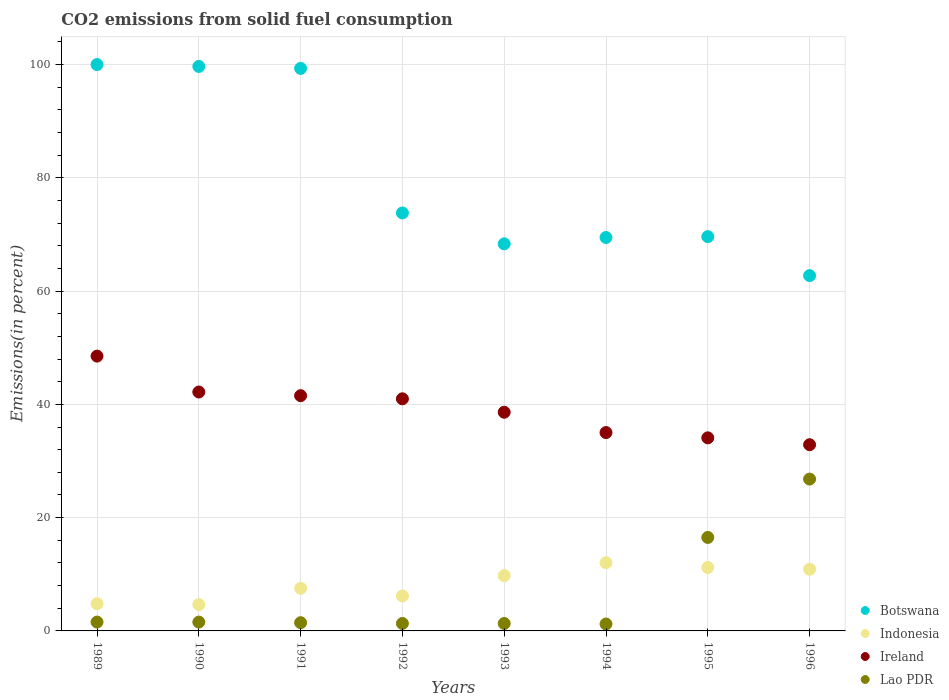Is the number of dotlines equal to the number of legend labels?
Keep it short and to the point. Yes. What is the total CO2 emitted in Ireland in 1990?
Give a very brief answer. 42.18. Across all years, what is the minimum total CO2 emitted in Botswana?
Give a very brief answer. 62.73. In which year was the total CO2 emitted in Ireland maximum?
Your answer should be compact. 1989. In which year was the total CO2 emitted in Botswana minimum?
Give a very brief answer. 1996. What is the total total CO2 emitted in Lao PDR in the graph?
Offer a terse response. 51.74. What is the difference between the total CO2 emitted in Lao PDR in 1989 and that in 1995?
Your answer should be very brief. -14.94. What is the difference between the total CO2 emitted in Ireland in 1994 and the total CO2 emitted in Indonesia in 1989?
Make the answer very short. 30.22. What is the average total CO2 emitted in Lao PDR per year?
Offer a terse response. 6.47. In the year 1993, what is the difference between the total CO2 emitted in Botswana and total CO2 emitted in Indonesia?
Your answer should be compact. 58.59. In how many years, is the total CO2 emitted in Ireland greater than 4 %?
Your answer should be compact. 8. What is the ratio of the total CO2 emitted in Ireland in 1989 to that in 1995?
Ensure brevity in your answer.  1.42. What is the difference between the highest and the second highest total CO2 emitted in Ireland?
Offer a terse response. 6.34. What is the difference between the highest and the lowest total CO2 emitted in Ireland?
Make the answer very short. 15.64. Is it the case that in every year, the sum of the total CO2 emitted in Lao PDR and total CO2 emitted in Indonesia  is greater than the sum of total CO2 emitted in Ireland and total CO2 emitted in Botswana?
Offer a very short reply. No. Is the total CO2 emitted in Botswana strictly less than the total CO2 emitted in Ireland over the years?
Your answer should be very brief. No. How many dotlines are there?
Keep it short and to the point. 4. What is the difference between two consecutive major ticks on the Y-axis?
Provide a succinct answer. 20. Are the values on the major ticks of Y-axis written in scientific E-notation?
Offer a very short reply. No. Does the graph contain any zero values?
Keep it short and to the point. No. Does the graph contain grids?
Provide a succinct answer. Yes. Where does the legend appear in the graph?
Offer a terse response. Bottom right. How are the legend labels stacked?
Provide a short and direct response. Vertical. What is the title of the graph?
Provide a short and direct response. CO2 emissions from solid fuel consumption. What is the label or title of the X-axis?
Keep it short and to the point. Years. What is the label or title of the Y-axis?
Provide a succinct answer. Emissions(in percent). What is the Emissions(in percent) of Botswana in 1989?
Provide a succinct answer. 100. What is the Emissions(in percent) of Indonesia in 1989?
Ensure brevity in your answer.  4.8. What is the Emissions(in percent) in Ireland in 1989?
Provide a succinct answer. 48.52. What is the Emissions(in percent) of Lao PDR in 1989?
Your answer should be very brief. 1.56. What is the Emissions(in percent) of Botswana in 1990?
Your answer should be compact. 99.66. What is the Emissions(in percent) in Indonesia in 1990?
Provide a succinct answer. 4.65. What is the Emissions(in percent) of Ireland in 1990?
Make the answer very short. 42.18. What is the Emissions(in percent) in Lao PDR in 1990?
Keep it short and to the point. 1.56. What is the Emissions(in percent) in Botswana in 1991?
Your answer should be compact. 99.32. What is the Emissions(in percent) in Indonesia in 1991?
Your answer should be very brief. 7.53. What is the Emissions(in percent) in Ireland in 1991?
Provide a succinct answer. 41.53. What is the Emissions(in percent) of Lao PDR in 1991?
Provide a succinct answer. 1.45. What is the Emissions(in percent) in Botswana in 1992?
Offer a very short reply. 73.8. What is the Emissions(in percent) of Indonesia in 1992?
Offer a very short reply. 6.18. What is the Emissions(in percent) of Ireland in 1992?
Offer a very short reply. 40.98. What is the Emissions(in percent) of Lao PDR in 1992?
Provide a short and direct response. 1.32. What is the Emissions(in percent) in Botswana in 1993?
Provide a short and direct response. 68.34. What is the Emissions(in percent) of Indonesia in 1993?
Keep it short and to the point. 9.76. What is the Emissions(in percent) in Ireland in 1993?
Offer a very short reply. 38.61. What is the Emissions(in percent) of Lao PDR in 1993?
Offer a terse response. 1.32. What is the Emissions(in percent) in Botswana in 1994?
Give a very brief answer. 69.46. What is the Emissions(in percent) of Indonesia in 1994?
Provide a short and direct response. 12.05. What is the Emissions(in percent) in Ireland in 1994?
Your answer should be compact. 35.02. What is the Emissions(in percent) in Lao PDR in 1994?
Make the answer very short. 1.22. What is the Emissions(in percent) in Botswana in 1995?
Your response must be concise. 69.61. What is the Emissions(in percent) in Indonesia in 1995?
Your answer should be compact. 11.2. What is the Emissions(in percent) of Ireland in 1995?
Offer a terse response. 34.09. What is the Emissions(in percent) in Lao PDR in 1995?
Provide a short and direct response. 16.5. What is the Emissions(in percent) of Botswana in 1996?
Give a very brief answer. 62.73. What is the Emissions(in percent) of Indonesia in 1996?
Your answer should be compact. 10.89. What is the Emissions(in percent) in Ireland in 1996?
Give a very brief answer. 32.88. What is the Emissions(in percent) in Lao PDR in 1996?
Offer a very short reply. 26.81. Across all years, what is the maximum Emissions(in percent) in Botswana?
Provide a succinct answer. 100. Across all years, what is the maximum Emissions(in percent) of Indonesia?
Ensure brevity in your answer.  12.05. Across all years, what is the maximum Emissions(in percent) of Ireland?
Give a very brief answer. 48.52. Across all years, what is the maximum Emissions(in percent) in Lao PDR?
Offer a very short reply. 26.81. Across all years, what is the minimum Emissions(in percent) of Botswana?
Your answer should be very brief. 62.73. Across all years, what is the minimum Emissions(in percent) in Indonesia?
Give a very brief answer. 4.65. Across all years, what is the minimum Emissions(in percent) in Ireland?
Provide a short and direct response. 32.88. Across all years, what is the minimum Emissions(in percent) in Lao PDR?
Give a very brief answer. 1.22. What is the total Emissions(in percent) in Botswana in the graph?
Make the answer very short. 642.93. What is the total Emissions(in percent) of Indonesia in the graph?
Ensure brevity in your answer.  67.05. What is the total Emissions(in percent) in Ireland in the graph?
Make the answer very short. 313.82. What is the total Emissions(in percent) in Lao PDR in the graph?
Provide a short and direct response. 51.74. What is the difference between the Emissions(in percent) of Botswana in 1989 and that in 1990?
Your answer should be very brief. 0.34. What is the difference between the Emissions(in percent) in Indonesia in 1989 and that in 1990?
Offer a terse response. 0.15. What is the difference between the Emissions(in percent) in Ireland in 1989 and that in 1990?
Make the answer very short. 6.34. What is the difference between the Emissions(in percent) in Botswana in 1989 and that in 1991?
Ensure brevity in your answer.  0.68. What is the difference between the Emissions(in percent) in Indonesia in 1989 and that in 1991?
Ensure brevity in your answer.  -2.73. What is the difference between the Emissions(in percent) of Ireland in 1989 and that in 1991?
Provide a succinct answer. 6.99. What is the difference between the Emissions(in percent) of Lao PDR in 1989 and that in 1991?
Your answer should be very brief. 0.11. What is the difference between the Emissions(in percent) in Botswana in 1989 and that in 1992?
Keep it short and to the point. 26.2. What is the difference between the Emissions(in percent) in Indonesia in 1989 and that in 1992?
Your answer should be compact. -1.38. What is the difference between the Emissions(in percent) of Ireland in 1989 and that in 1992?
Provide a short and direct response. 7.54. What is the difference between the Emissions(in percent) of Lao PDR in 1989 and that in 1992?
Keep it short and to the point. 0.25. What is the difference between the Emissions(in percent) of Botswana in 1989 and that in 1993?
Make the answer very short. 31.66. What is the difference between the Emissions(in percent) in Indonesia in 1989 and that in 1993?
Your response must be concise. -4.96. What is the difference between the Emissions(in percent) in Ireland in 1989 and that in 1993?
Provide a succinct answer. 9.91. What is the difference between the Emissions(in percent) of Lao PDR in 1989 and that in 1993?
Offer a very short reply. 0.25. What is the difference between the Emissions(in percent) of Botswana in 1989 and that in 1994?
Ensure brevity in your answer.  30.54. What is the difference between the Emissions(in percent) in Indonesia in 1989 and that in 1994?
Provide a succinct answer. -7.25. What is the difference between the Emissions(in percent) in Ireland in 1989 and that in 1994?
Offer a terse response. 13.5. What is the difference between the Emissions(in percent) in Lao PDR in 1989 and that in 1994?
Your response must be concise. 0.34. What is the difference between the Emissions(in percent) of Botswana in 1989 and that in 1995?
Make the answer very short. 30.39. What is the difference between the Emissions(in percent) in Indonesia in 1989 and that in 1995?
Provide a succinct answer. -6.4. What is the difference between the Emissions(in percent) of Ireland in 1989 and that in 1995?
Make the answer very short. 14.43. What is the difference between the Emissions(in percent) of Lao PDR in 1989 and that in 1995?
Keep it short and to the point. -14.94. What is the difference between the Emissions(in percent) of Botswana in 1989 and that in 1996?
Offer a terse response. 37.27. What is the difference between the Emissions(in percent) of Indonesia in 1989 and that in 1996?
Provide a short and direct response. -6.09. What is the difference between the Emissions(in percent) of Ireland in 1989 and that in 1996?
Your response must be concise. 15.64. What is the difference between the Emissions(in percent) of Lao PDR in 1989 and that in 1996?
Ensure brevity in your answer.  -25.25. What is the difference between the Emissions(in percent) in Botswana in 1990 and that in 1991?
Make the answer very short. 0.35. What is the difference between the Emissions(in percent) of Indonesia in 1990 and that in 1991?
Ensure brevity in your answer.  -2.88. What is the difference between the Emissions(in percent) of Ireland in 1990 and that in 1991?
Offer a terse response. 0.65. What is the difference between the Emissions(in percent) of Lao PDR in 1990 and that in 1991?
Keep it short and to the point. 0.11. What is the difference between the Emissions(in percent) of Botswana in 1990 and that in 1992?
Make the answer very short. 25.87. What is the difference between the Emissions(in percent) of Indonesia in 1990 and that in 1992?
Your response must be concise. -1.53. What is the difference between the Emissions(in percent) in Ireland in 1990 and that in 1992?
Your answer should be very brief. 1.2. What is the difference between the Emissions(in percent) of Lao PDR in 1990 and that in 1992?
Your answer should be compact. 0.25. What is the difference between the Emissions(in percent) of Botswana in 1990 and that in 1993?
Offer a terse response. 31.32. What is the difference between the Emissions(in percent) in Indonesia in 1990 and that in 1993?
Provide a short and direct response. -5.11. What is the difference between the Emissions(in percent) of Ireland in 1990 and that in 1993?
Your answer should be compact. 3.57. What is the difference between the Emissions(in percent) of Lao PDR in 1990 and that in 1993?
Offer a very short reply. 0.25. What is the difference between the Emissions(in percent) in Botswana in 1990 and that in 1994?
Make the answer very short. 30.2. What is the difference between the Emissions(in percent) in Indonesia in 1990 and that in 1994?
Your answer should be compact. -7.4. What is the difference between the Emissions(in percent) in Ireland in 1990 and that in 1994?
Offer a terse response. 7.16. What is the difference between the Emissions(in percent) of Lao PDR in 1990 and that in 1994?
Offer a terse response. 0.34. What is the difference between the Emissions(in percent) of Botswana in 1990 and that in 1995?
Give a very brief answer. 30.05. What is the difference between the Emissions(in percent) in Indonesia in 1990 and that in 1995?
Make the answer very short. -6.55. What is the difference between the Emissions(in percent) of Ireland in 1990 and that in 1995?
Ensure brevity in your answer.  8.09. What is the difference between the Emissions(in percent) of Lao PDR in 1990 and that in 1995?
Offer a terse response. -14.94. What is the difference between the Emissions(in percent) of Botswana in 1990 and that in 1996?
Your answer should be very brief. 36.93. What is the difference between the Emissions(in percent) of Indonesia in 1990 and that in 1996?
Keep it short and to the point. -6.24. What is the difference between the Emissions(in percent) of Ireland in 1990 and that in 1996?
Give a very brief answer. 9.3. What is the difference between the Emissions(in percent) in Lao PDR in 1990 and that in 1996?
Provide a succinct answer. -25.25. What is the difference between the Emissions(in percent) of Botswana in 1991 and that in 1992?
Offer a terse response. 25.52. What is the difference between the Emissions(in percent) in Indonesia in 1991 and that in 1992?
Make the answer very short. 1.35. What is the difference between the Emissions(in percent) in Ireland in 1991 and that in 1992?
Provide a short and direct response. 0.55. What is the difference between the Emissions(in percent) of Lao PDR in 1991 and that in 1992?
Ensure brevity in your answer.  0.13. What is the difference between the Emissions(in percent) of Botswana in 1991 and that in 1993?
Offer a very short reply. 30.97. What is the difference between the Emissions(in percent) in Indonesia in 1991 and that in 1993?
Offer a terse response. -2.23. What is the difference between the Emissions(in percent) in Ireland in 1991 and that in 1993?
Your answer should be compact. 2.92. What is the difference between the Emissions(in percent) of Lao PDR in 1991 and that in 1993?
Ensure brevity in your answer.  0.13. What is the difference between the Emissions(in percent) of Botswana in 1991 and that in 1994?
Your answer should be very brief. 29.85. What is the difference between the Emissions(in percent) of Indonesia in 1991 and that in 1994?
Ensure brevity in your answer.  -4.52. What is the difference between the Emissions(in percent) of Ireland in 1991 and that in 1994?
Keep it short and to the point. 6.51. What is the difference between the Emissions(in percent) in Lao PDR in 1991 and that in 1994?
Provide a succinct answer. 0.23. What is the difference between the Emissions(in percent) in Botswana in 1991 and that in 1995?
Your answer should be compact. 29.7. What is the difference between the Emissions(in percent) in Indonesia in 1991 and that in 1995?
Offer a terse response. -3.67. What is the difference between the Emissions(in percent) in Ireland in 1991 and that in 1995?
Provide a short and direct response. 7.44. What is the difference between the Emissions(in percent) of Lao PDR in 1991 and that in 1995?
Ensure brevity in your answer.  -15.06. What is the difference between the Emissions(in percent) in Botswana in 1991 and that in 1996?
Keep it short and to the point. 36.58. What is the difference between the Emissions(in percent) in Indonesia in 1991 and that in 1996?
Give a very brief answer. -3.36. What is the difference between the Emissions(in percent) of Ireland in 1991 and that in 1996?
Give a very brief answer. 8.66. What is the difference between the Emissions(in percent) of Lao PDR in 1991 and that in 1996?
Offer a very short reply. -25.36. What is the difference between the Emissions(in percent) in Botswana in 1992 and that in 1993?
Give a very brief answer. 5.45. What is the difference between the Emissions(in percent) in Indonesia in 1992 and that in 1993?
Your answer should be very brief. -3.58. What is the difference between the Emissions(in percent) in Ireland in 1992 and that in 1993?
Keep it short and to the point. 2.37. What is the difference between the Emissions(in percent) in Botswana in 1992 and that in 1994?
Provide a short and direct response. 4.33. What is the difference between the Emissions(in percent) in Indonesia in 1992 and that in 1994?
Offer a terse response. -5.87. What is the difference between the Emissions(in percent) of Ireland in 1992 and that in 1994?
Provide a succinct answer. 5.96. What is the difference between the Emissions(in percent) in Lao PDR in 1992 and that in 1994?
Offer a very short reply. 0.1. What is the difference between the Emissions(in percent) of Botswana in 1992 and that in 1995?
Make the answer very short. 4.18. What is the difference between the Emissions(in percent) of Indonesia in 1992 and that in 1995?
Your response must be concise. -5.02. What is the difference between the Emissions(in percent) of Ireland in 1992 and that in 1995?
Offer a terse response. 6.89. What is the difference between the Emissions(in percent) of Lao PDR in 1992 and that in 1995?
Provide a succinct answer. -15.19. What is the difference between the Emissions(in percent) of Botswana in 1992 and that in 1996?
Keep it short and to the point. 11.06. What is the difference between the Emissions(in percent) of Indonesia in 1992 and that in 1996?
Give a very brief answer. -4.71. What is the difference between the Emissions(in percent) of Ireland in 1992 and that in 1996?
Give a very brief answer. 8.1. What is the difference between the Emissions(in percent) of Lao PDR in 1992 and that in 1996?
Ensure brevity in your answer.  -25.5. What is the difference between the Emissions(in percent) of Botswana in 1993 and that in 1994?
Give a very brief answer. -1.12. What is the difference between the Emissions(in percent) in Indonesia in 1993 and that in 1994?
Provide a short and direct response. -2.29. What is the difference between the Emissions(in percent) of Ireland in 1993 and that in 1994?
Give a very brief answer. 3.59. What is the difference between the Emissions(in percent) of Lao PDR in 1993 and that in 1994?
Provide a succinct answer. 0.1. What is the difference between the Emissions(in percent) of Botswana in 1993 and that in 1995?
Provide a short and direct response. -1.27. What is the difference between the Emissions(in percent) of Indonesia in 1993 and that in 1995?
Your answer should be very brief. -1.44. What is the difference between the Emissions(in percent) of Ireland in 1993 and that in 1995?
Offer a terse response. 4.52. What is the difference between the Emissions(in percent) of Lao PDR in 1993 and that in 1995?
Ensure brevity in your answer.  -15.19. What is the difference between the Emissions(in percent) in Botswana in 1993 and that in 1996?
Provide a succinct answer. 5.61. What is the difference between the Emissions(in percent) of Indonesia in 1993 and that in 1996?
Make the answer very short. -1.13. What is the difference between the Emissions(in percent) of Ireland in 1993 and that in 1996?
Your answer should be very brief. 5.73. What is the difference between the Emissions(in percent) in Lao PDR in 1993 and that in 1996?
Offer a terse response. -25.5. What is the difference between the Emissions(in percent) of Botswana in 1994 and that in 1995?
Offer a very short reply. -0.15. What is the difference between the Emissions(in percent) of Indonesia in 1994 and that in 1995?
Ensure brevity in your answer.  0.84. What is the difference between the Emissions(in percent) in Ireland in 1994 and that in 1995?
Your answer should be compact. 0.93. What is the difference between the Emissions(in percent) in Lao PDR in 1994 and that in 1995?
Your answer should be compact. -15.29. What is the difference between the Emissions(in percent) in Botswana in 1994 and that in 1996?
Keep it short and to the point. 6.73. What is the difference between the Emissions(in percent) of Indonesia in 1994 and that in 1996?
Ensure brevity in your answer.  1.16. What is the difference between the Emissions(in percent) of Ireland in 1994 and that in 1996?
Give a very brief answer. 2.14. What is the difference between the Emissions(in percent) of Lao PDR in 1994 and that in 1996?
Your response must be concise. -25.59. What is the difference between the Emissions(in percent) in Botswana in 1995 and that in 1996?
Give a very brief answer. 6.88. What is the difference between the Emissions(in percent) of Indonesia in 1995 and that in 1996?
Offer a terse response. 0.31. What is the difference between the Emissions(in percent) of Ireland in 1995 and that in 1996?
Your answer should be compact. 1.21. What is the difference between the Emissions(in percent) of Lao PDR in 1995 and that in 1996?
Your answer should be very brief. -10.31. What is the difference between the Emissions(in percent) in Botswana in 1989 and the Emissions(in percent) in Indonesia in 1990?
Your answer should be compact. 95.35. What is the difference between the Emissions(in percent) of Botswana in 1989 and the Emissions(in percent) of Ireland in 1990?
Provide a short and direct response. 57.82. What is the difference between the Emissions(in percent) in Botswana in 1989 and the Emissions(in percent) in Lao PDR in 1990?
Give a very brief answer. 98.44. What is the difference between the Emissions(in percent) in Indonesia in 1989 and the Emissions(in percent) in Ireland in 1990?
Your answer should be compact. -37.38. What is the difference between the Emissions(in percent) in Indonesia in 1989 and the Emissions(in percent) in Lao PDR in 1990?
Your answer should be very brief. 3.24. What is the difference between the Emissions(in percent) of Ireland in 1989 and the Emissions(in percent) of Lao PDR in 1990?
Keep it short and to the point. 46.96. What is the difference between the Emissions(in percent) of Botswana in 1989 and the Emissions(in percent) of Indonesia in 1991?
Your response must be concise. 92.47. What is the difference between the Emissions(in percent) of Botswana in 1989 and the Emissions(in percent) of Ireland in 1991?
Your answer should be compact. 58.47. What is the difference between the Emissions(in percent) in Botswana in 1989 and the Emissions(in percent) in Lao PDR in 1991?
Give a very brief answer. 98.55. What is the difference between the Emissions(in percent) of Indonesia in 1989 and the Emissions(in percent) of Ireland in 1991?
Your response must be concise. -36.73. What is the difference between the Emissions(in percent) of Indonesia in 1989 and the Emissions(in percent) of Lao PDR in 1991?
Make the answer very short. 3.35. What is the difference between the Emissions(in percent) in Ireland in 1989 and the Emissions(in percent) in Lao PDR in 1991?
Ensure brevity in your answer.  47.07. What is the difference between the Emissions(in percent) of Botswana in 1989 and the Emissions(in percent) of Indonesia in 1992?
Your answer should be compact. 93.82. What is the difference between the Emissions(in percent) in Botswana in 1989 and the Emissions(in percent) in Ireland in 1992?
Keep it short and to the point. 59.02. What is the difference between the Emissions(in percent) in Botswana in 1989 and the Emissions(in percent) in Lao PDR in 1992?
Your response must be concise. 98.68. What is the difference between the Emissions(in percent) in Indonesia in 1989 and the Emissions(in percent) in Ireland in 1992?
Your answer should be very brief. -36.18. What is the difference between the Emissions(in percent) of Indonesia in 1989 and the Emissions(in percent) of Lao PDR in 1992?
Provide a short and direct response. 3.48. What is the difference between the Emissions(in percent) in Ireland in 1989 and the Emissions(in percent) in Lao PDR in 1992?
Keep it short and to the point. 47.21. What is the difference between the Emissions(in percent) of Botswana in 1989 and the Emissions(in percent) of Indonesia in 1993?
Ensure brevity in your answer.  90.24. What is the difference between the Emissions(in percent) in Botswana in 1989 and the Emissions(in percent) in Ireland in 1993?
Your response must be concise. 61.39. What is the difference between the Emissions(in percent) of Botswana in 1989 and the Emissions(in percent) of Lao PDR in 1993?
Provide a succinct answer. 98.68. What is the difference between the Emissions(in percent) of Indonesia in 1989 and the Emissions(in percent) of Ireland in 1993?
Your response must be concise. -33.81. What is the difference between the Emissions(in percent) in Indonesia in 1989 and the Emissions(in percent) in Lao PDR in 1993?
Provide a succinct answer. 3.48. What is the difference between the Emissions(in percent) in Ireland in 1989 and the Emissions(in percent) in Lao PDR in 1993?
Offer a very short reply. 47.21. What is the difference between the Emissions(in percent) in Botswana in 1989 and the Emissions(in percent) in Indonesia in 1994?
Your answer should be very brief. 87.95. What is the difference between the Emissions(in percent) of Botswana in 1989 and the Emissions(in percent) of Ireland in 1994?
Ensure brevity in your answer.  64.98. What is the difference between the Emissions(in percent) in Botswana in 1989 and the Emissions(in percent) in Lao PDR in 1994?
Your answer should be compact. 98.78. What is the difference between the Emissions(in percent) in Indonesia in 1989 and the Emissions(in percent) in Ireland in 1994?
Give a very brief answer. -30.22. What is the difference between the Emissions(in percent) of Indonesia in 1989 and the Emissions(in percent) of Lao PDR in 1994?
Your answer should be very brief. 3.58. What is the difference between the Emissions(in percent) of Ireland in 1989 and the Emissions(in percent) of Lao PDR in 1994?
Offer a terse response. 47.3. What is the difference between the Emissions(in percent) in Botswana in 1989 and the Emissions(in percent) in Indonesia in 1995?
Your response must be concise. 88.8. What is the difference between the Emissions(in percent) of Botswana in 1989 and the Emissions(in percent) of Ireland in 1995?
Your answer should be compact. 65.91. What is the difference between the Emissions(in percent) of Botswana in 1989 and the Emissions(in percent) of Lao PDR in 1995?
Make the answer very short. 83.5. What is the difference between the Emissions(in percent) in Indonesia in 1989 and the Emissions(in percent) in Ireland in 1995?
Your answer should be very brief. -29.29. What is the difference between the Emissions(in percent) of Indonesia in 1989 and the Emissions(in percent) of Lao PDR in 1995?
Provide a short and direct response. -11.71. What is the difference between the Emissions(in percent) in Ireland in 1989 and the Emissions(in percent) in Lao PDR in 1995?
Your answer should be very brief. 32.02. What is the difference between the Emissions(in percent) in Botswana in 1989 and the Emissions(in percent) in Indonesia in 1996?
Offer a terse response. 89.11. What is the difference between the Emissions(in percent) in Botswana in 1989 and the Emissions(in percent) in Ireland in 1996?
Make the answer very short. 67.12. What is the difference between the Emissions(in percent) in Botswana in 1989 and the Emissions(in percent) in Lao PDR in 1996?
Offer a very short reply. 73.19. What is the difference between the Emissions(in percent) in Indonesia in 1989 and the Emissions(in percent) in Ireland in 1996?
Your answer should be compact. -28.08. What is the difference between the Emissions(in percent) in Indonesia in 1989 and the Emissions(in percent) in Lao PDR in 1996?
Your response must be concise. -22.01. What is the difference between the Emissions(in percent) of Ireland in 1989 and the Emissions(in percent) of Lao PDR in 1996?
Your answer should be compact. 21.71. What is the difference between the Emissions(in percent) of Botswana in 1990 and the Emissions(in percent) of Indonesia in 1991?
Keep it short and to the point. 92.13. What is the difference between the Emissions(in percent) in Botswana in 1990 and the Emissions(in percent) in Ireland in 1991?
Provide a short and direct response. 58.13. What is the difference between the Emissions(in percent) in Botswana in 1990 and the Emissions(in percent) in Lao PDR in 1991?
Provide a short and direct response. 98.21. What is the difference between the Emissions(in percent) in Indonesia in 1990 and the Emissions(in percent) in Ireland in 1991?
Your answer should be compact. -36.88. What is the difference between the Emissions(in percent) of Indonesia in 1990 and the Emissions(in percent) of Lao PDR in 1991?
Offer a terse response. 3.2. What is the difference between the Emissions(in percent) of Ireland in 1990 and the Emissions(in percent) of Lao PDR in 1991?
Your answer should be compact. 40.73. What is the difference between the Emissions(in percent) of Botswana in 1990 and the Emissions(in percent) of Indonesia in 1992?
Provide a short and direct response. 93.48. What is the difference between the Emissions(in percent) in Botswana in 1990 and the Emissions(in percent) in Ireland in 1992?
Keep it short and to the point. 58.68. What is the difference between the Emissions(in percent) in Botswana in 1990 and the Emissions(in percent) in Lao PDR in 1992?
Provide a succinct answer. 98.35. What is the difference between the Emissions(in percent) of Indonesia in 1990 and the Emissions(in percent) of Ireland in 1992?
Offer a terse response. -36.33. What is the difference between the Emissions(in percent) in Indonesia in 1990 and the Emissions(in percent) in Lao PDR in 1992?
Offer a terse response. 3.33. What is the difference between the Emissions(in percent) of Ireland in 1990 and the Emissions(in percent) of Lao PDR in 1992?
Keep it short and to the point. 40.87. What is the difference between the Emissions(in percent) of Botswana in 1990 and the Emissions(in percent) of Indonesia in 1993?
Your response must be concise. 89.91. What is the difference between the Emissions(in percent) of Botswana in 1990 and the Emissions(in percent) of Ireland in 1993?
Give a very brief answer. 61.05. What is the difference between the Emissions(in percent) in Botswana in 1990 and the Emissions(in percent) in Lao PDR in 1993?
Your answer should be very brief. 98.35. What is the difference between the Emissions(in percent) of Indonesia in 1990 and the Emissions(in percent) of Ireland in 1993?
Provide a succinct answer. -33.96. What is the difference between the Emissions(in percent) in Indonesia in 1990 and the Emissions(in percent) in Lao PDR in 1993?
Offer a terse response. 3.33. What is the difference between the Emissions(in percent) of Ireland in 1990 and the Emissions(in percent) of Lao PDR in 1993?
Your response must be concise. 40.87. What is the difference between the Emissions(in percent) in Botswana in 1990 and the Emissions(in percent) in Indonesia in 1994?
Your answer should be compact. 87.62. What is the difference between the Emissions(in percent) in Botswana in 1990 and the Emissions(in percent) in Ireland in 1994?
Your response must be concise. 64.64. What is the difference between the Emissions(in percent) in Botswana in 1990 and the Emissions(in percent) in Lao PDR in 1994?
Your answer should be very brief. 98.44. What is the difference between the Emissions(in percent) in Indonesia in 1990 and the Emissions(in percent) in Ireland in 1994?
Give a very brief answer. -30.37. What is the difference between the Emissions(in percent) of Indonesia in 1990 and the Emissions(in percent) of Lao PDR in 1994?
Make the answer very short. 3.43. What is the difference between the Emissions(in percent) of Ireland in 1990 and the Emissions(in percent) of Lao PDR in 1994?
Provide a short and direct response. 40.96. What is the difference between the Emissions(in percent) of Botswana in 1990 and the Emissions(in percent) of Indonesia in 1995?
Offer a terse response. 88.46. What is the difference between the Emissions(in percent) in Botswana in 1990 and the Emissions(in percent) in Ireland in 1995?
Offer a terse response. 65.57. What is the difference between the Emissions(in percent) in Botswana in 1990 and the Emissions(in percent) in Lao PDR in 1995?
Keep it short and to the point. 83.16. What is the difference between the Emissions(in percent) in Indonesia in 1990 and the Emissions(in percent) in Ireland in 1995?
Offer a very short reply. -29.44. What is the difference between the Emissions(in percent) of Indonesia in 1990 and the Emissions(in percent) of Lao PDR in 1995?
Keep it short and to the point. -11.86. What is the difference between the Emissions(in percent) of Ireland in 1990 and the Emissions(in percent) of Lao PDR in 1995?
Make the answer very short. 25.68. What is the difference between the Emissions(in percent) in Botswana in 1990 and the Emissions(in percent) in Indonesia in 1996?
Make the answer very short. 88.77. What is the difference between the Emissions(in percent) of Botswana in 1990 and the Emissions(in percent) of Ireland in 1996?
Give a very brief answer. 66.79. What is the difference between the Emissions(in percent) of Botswana in 1990 and the Emissions(in percent) of Lao PDR in 1996?
Your answer should be compact. 72.85. What is the difference between the Emissions(in percent) of Indonesia in 1990 and the Emissions(in percent) of Ireland in 1996?
Provide a short and direct response. -28.23. What is the difference between the Emissions(in percent) of Indonesia in 1990 and the Emissions(in percent) of Lao PDR in 1996?
Make the answer very short. -22.16. What is the difference between the Emissions(in percent) in Ireland in 1990 and the Emissions(in percent) in Lao PDR in 1996?
Provide a succinct answer. 15.37. What is the difference between the Emissions(in percent) of Botswana in 1991 and the Emissions(in percent) of Indonesia in 1992?
Keep it short and to the point. 93.14. What is the difference between the Emissions(in percent) in Botswana in 1991 and the Emissions(in percent) in Ireland in 1992?
Your answer should be very brief. 58.34. What is the difference between the Emissions(in percent) in Botswana in 1991 and the Emissions(in percent) in Lao PDR in 1992?
Ensure brevity in your answer.  98. What is the difference between the Emissions(in percent) of Indonesia in 1991 and the Emissions(in percent) of Ireland in 1992?
Your answer should be compact. -33.45. What is the difference between the Emissions(in percent) of Indonesia in 1991 and the Emissions(in percent) of Lao PDR in 1992?
Give a very brief answer. 6.21. What is the difference between the Emissions(in percent) of Ireland in 1991 and the Emissions(in percent) of Lao PDR in 1992?
Offer a very short reply. 40.22. What is the difference between the Emissions(in percent) in Botswana in 1991 and the Emissions(in percent) in Indonesia in 1993?
Your response must be concise. 89.56. What is the difference between the Emissions(in percent) of Botswana in 1991 and the Emissions(in percent) of Ireland in 1993?
Give a very brief answer. 60.71. What is the difference between the Emissions(in percent) of Botswana in 1991 and the Emissions(in percent) of Lao PDR in 1993?
Give a very brief answer. 98. What is the difference between the Emissions(in percent) of Indonesia in 1991 and the Emissions(in percent) of Ireland in 1993?
Give a very brief answer. -31.08. What is the difference between the Emissions(in percent) of Indonesia in 1991 and the Emissions(in percent) of Lao PDR in 1993?
Provide a succinct answer. 6.21. What is the difference between the Emissions(in percent) of Ireland in 1991 and the Emissions(in percent) of Lao PDR in 1993?
Your answer should be compact. 40.22. What is the difference between the Emissions(in percent) of Botswana in 1991 and the Emissions(in percent) of Indonesia in 1994?
Ensure brevity in your answer.  87.27. What is the difference between the Emissions(in percent) in Botswana in 1991 and the Emissions(in percent) in Ireland in 1994?
Give a very brief answer. 64.3. What is the difference between the Emissions(in percent) of Botswana in 1991 and the Emissions(in percent) of Lao PDR in 1994?
Provide a short and direct response. 98.1. What is the difference between the Emissions(in percent) in Indonesia in 1991 and the Emissions(in percent) in Ireland in 1994?
Offer a very short reply. -27.49. What is the difference between the Emissions(in percent) in Indonesia in 1991 and the Emissions(in percent) in Lao PDR in 1994?
Make the answer very short. 6.31. What is the difference between the Emissions(in percent) of Ireland in 1991 and the Emissions(in percent) of Lao PDR in 1994?
Provide a short and direct response. 40.31. What is the difference between the Emissions(in percent) of Botswana in 1991 and the Emissions(in percent) of Indonesia in 1995?
Provide a short and direct response. 88.12. What is the difference between the Emissions(in percent) in Botswana in 1991 and the Emissions(in percent) in Ireland in 1995?
Your answer should be compact. 65.23. What is the difference between the Emissions(in percent) of Botswana in 1991 and the Emissions(in percent) of Lao PDR in 1995?
Provide a succinct answer. 82.81. What is the difference between the Emissions(in percent) in Indonesia in 1991 and the Emissions(in percent) in Ireland in 1995?
Offer a very short reply. -26.56. What is the difference between the Emissions(in percent) in Indonesia in 1991 and the Emissions(in percent) in Lao PDR in 1995?
Offer a terse response. -8.98. What is the difference between the Emissions(in percent) of Ireland in 1991 and the Emissions(in percent) of Lao PDR in 1995?
Keep it short and to the point. 25.03. What is the difference between the Emissions(in percent) of Botswana in 1991 and the Emissions(in percent) of Indonesia in 1996?
Your answer should be very brief. 88.43. What is the difference between the Emissions(in percent) of Botswana in 1991 and the Emissions(in percent) of Ireland in 1996?
Provide a succinct answer. 66.44. What is the difference between the Emissions(in percent) of Botswana in 1991 and the Emissions(in percent) of Lao PDR in 1996?
Your answer should be very brief. 72.51. What is the difference between the Emissions(in percent) of Indonesia in 1991 and the Emissions(in percent) of Ireland in 1996?
Ensure brevity in your answer.  -25.35. What is the difference between the Emissions(in percent) of Indonesia in 1991 and the Emissions(in percent) of Lao PDR in 1996?
Your response must be concise. -19.28. What is the difference between the Emissions(in percent) of Ireland in 1991 and the Emissions(in percent) of Lao PDR in 1996?
Your answer should be very brief. 14.72. What is the difference between the Emissions(in percent) of Botswana in 1992 and the Emissions(in percent) of Indonesia in 1993?
Offer a terse response. 64.04. What is the difference between the Emissions(in percent) in Botswana in 1992 and the Emissions(in percent) in Ireland in 1993?
Offer a terse response. 35.19. What is the difference between the Emissions(in percent) of Botswana in 1992 and the Emissions(in percent) of Lao PDR in 1993?
Make the answer very short. 72.48. What is the difference between the Emissions(in percent) of Indonesia in 1992 and the Emissions(in percent) of Ireland in 1993?
Offer a terse response. -32.43. What is the difference between the Emissions(in percent) in Indonesia in 1992 and the Emissions(in percent) in Lao PDR in 1993?
Your answer should be compact. 4.86. What is the difference between the Emissions(in percent) in Ireland in 1992 and the Emissions(in percent) in Lao PDR in 1993?
Provide a short and direct response. 39.67. What is the difference between the Emissions(in percent) of Botswana in 1992 and the Emissions(in percent) of Indonesia in 1994?
Make the answer very short. 61.75. What is the difference between the Emissions(in percent) of Botswana in 1992 and the Emissions(in percent) of Ireland in 1994?
Ensure brevity in your answer.  38.78. What is the difference between the Emissions(in percent) of Botswana in 1992 and the Emissions(in percent) of Lao PDR in 1994?
Your response must be concise. 72.58. What is the difference between the Emissions(in percent) of Indonesia in 1992 and the Emissions(in percent) of Ireland in 1994?
Your answer should be compact. -28.84. What is the difference between the Emissions(in percent) of Indonesia in 1992 and the Emissions(in percent) of Lao PDR in 1994?
Your answer should be compact. 4.96. What is the difference between the Emissions(in percent) of Ireland in 1992 and the Emissions(in percent) of Lao PDR in 1994?
Ensure brevity in your answer.  39.76. What is the difference between the Emissions(in percent) of Botswana in 1992 and the Emissions(in percent) of Indonesia in 1995?
Keep it short and to the point. 62.6. What is the difference between the Emissions(in percent) in Botswana in 1992 and the Emissions(in percent) in Ireland in 1995?
Ensure brevity in your answer.  39.71. What is the difference between the Emissions(in percent) in Botswana in 1992 and the Emissions(in percent) in Lao PDR in 1995?
Keep it short and to the point. 57.29. What is the difference between the Emissions(in percent) of Indonesia in 1992 and the Emissions(in percent) of Ireland in 1995?
Provide a succinct answer. -27.91. What is the difference between the Emissions(in percent) in Indonesia in 1992 and the Emissions(in percent) in Lao PDR in 1995?
Provide a short and direct response. -10.32. What is the difference between the Emissions(in percent) of Ireland in 1992 and the Emissions(in percent) of Lao PDR in 1995?
Provide a succinct answer. 24.48. What is the difference between the Emissions(in percent) of Botswana in 1992 and the Emissions(in percent) of Indonesia in 1996?
Make the answer very short. 62.91. What is the difference between the Emissions(in percent) in Botswana in 1992 and the Emissions(in percent) in Ireland in 1996?
Make the answer very short. 40.92. What is the difference between the Emissions(in percent) in Botswana in 1992 and the Emissions(in percent) in Lao PDR in 1996?
Your answer should be compact. 46.98. What is the difference between the Emissions(in percent) in Indonesia in 1992 and the Emissions(in percent) in Ireland in 1996?
Offer a terse response. -26.7. What is the difference between the Emissions(in percent) in Indonesia in 1992 and the Emissions(in percent) in Lao PDR in 1996?
Your response must be concise. -20.63. What is the difference between the Emissions(in percent) of Ireland in 1992 and the Emissions(in percent) of Lao PDR in 1996?
Provide a succinct answer. 14.17. What is the difference between the Emissions(in percent) of Botswana in 1993 and the Emissions(in percent) of Indonesia in 1994?
Provide a succinct answer. 56.3. What is the difference between the Emissions(in percent) in Botswana in 1993 and the Emissions(in percent) in Ireland in 1994?
Ensure brevity in your answer.  33.32. What is the difference between the Emissions(in percent) of Botswana in 1993 and the Emissions(in percent) of Lao PDR in 1994?
Offer a terse response. 67.12. What is the difference between the Emissions(in percent) in Indonesia in 1993 and the Emissions(in percent) in Ireland in 1994?
Your answer should be very brief. -25.26. What is the difference between the Emissions(in percent) in Indonesia in 1993 and the Emissions(in percent) in Lao PDR in 1994?
Your answer should be very brief. 8.54. What is the difference between the Emissions(in percent) in Ireland in 1993 and the Emissions(in percent) in Lao PDR in 1994?
Keep it short and to the point. 37.39. What is the difference between the Emissions(in percent) of Botswana in 1993 and the Emissions(in percent) of Indonesia in 1995?
Provide a succinct answer. 57.14. What is the difference between the Emissions(in percent) of Botswana in 1993 and the Emissions(in percent) of Ireland in 1995?
Provide a short and direct response. 34.25. What is the difference between the Emissions(in percent) of Botswana in 1993 and the Emissions(in percent) of Lao PDR in 1995?
Offer a terse response. 51.84. What is the difference between the Emissions(in percent) in Indonesia in 1993 and the Emissions(in percent) in Ireland in 1995?
Provide a succinct answer. -24.33. What is the difference between the Emissions(in percent) in Indonesia in 1993 and the Emissions(in percent) in Lao PDR in 1995?
Your answer should be compact. -6.75. What is the difference between the Emissions(in percent) of Ireland in 1993 and the Emissions(in percent) of Lao PDR in 1995?
Your answer should be compact. 22.1. What is the difference between the Emissions(in percent) of Botswana in 1993 and the Emissions(in percent) of Indonesia in 1996?
Provide a short and direct response. 57.45. What is the difference between the Emissions(in percent) of Botswana in 1993 and the Emissions(in percent) of Ireland in 1996?
Provide a succinct answer. 35.47. What is the difference between the Emissions(in percent) in Botswana in 1993 and the Emissions(in percent) in Lao PDR in 1996?
Your response must be concise. 41.53. What is the difference between the Emissions(in percent) of Indonesia in 1993 and the Emissions(in percent) of Ireland in 1996?
Ensure brevity in your answer.  -23.12. What is the difference between the Emissions(in percent) of Indonesia in 1993 and the Emissions(in percent) of Lao PDR in 1996?
Provide a short and direct response. -17.06. What is the difference between the Emissions(in percent) in Ireland in 1993 and the Emissions(in percent) in Lao PDR in 1996?
Your response must be concise. 11.8. What is the difference between the Emissions(in percent) in Botswana in 1994 and the Emissions(in percent) in Indonesia in 1995?
Offer a terse response. 58.26. What is the difference between the Emissions(in percent) of Botswana in 1994 and the Emissions(in percent) of Ireland in 1995?
Make the answer very short. 35.38. What is the difference between the Emissions(in percent) of Botswana in 1994 and the Emissions(in percent) of Lao PDR in 1995?
Your answer should be very brief. 52.96. What is the difference between the Emissions(in percent) of Indonesia in 1994 and the Emissions(in percent) of Ireland in 1995?
Offer a very short reply. -22.04. What is the difference between the Emissions(in percent) in Indonesia in 1994 and the Emissions(in percent) in Lao PDR in 1995?
Offer a terse response. -4.46. What is the difference between the Emissions(in percent) of Ireland in 1994 and the Emissions(in percent) of Lao PDR in 1995?
Keep it short and to the point. 18.52. What is the difference between the Emissions(in percent) of Botswana in 1994 and the Emissions(in percent) of Indonesia in 1996?
Ensure brevity in your answer.  58.57. What is the difference between the Emissions(in percent) in Botswana in 1994 and the Emissions(in percent) in Ireland in 1996?
Your answer should be very brief. 36.59. What is the difference between the Emissions(in percent) in Botswana in 1994 and the Emissions(in percent) in Lao PDR in 1996?
Provide a short and direct response. 42.65. What is the difference between the Emissions(in percent) of Indonesia in 1994 and the Emissions(in percent) of Ireland in 1996?
Provide a short and direct response. -20.83. What is the difference between the Emissions(in percent) in Indonesia in 1994 and the Emissions(in percent) in Lao PDR in 1996?
Make the answer very short. -14.77. What is the difference between the Emissions(in percent) of Ireland in 1994 and the Emissions(in percent) of Lao PDR in 1996?
Make the answer very short. 8.21. What is the difference between the Emissions(in percent) of Botswana in 1995 and the Emissions(in percent) of Indonesia in 1996?
Your response must be concise. 58.73. What is the difference between the Emissions(in percent) of Botswana in 1995 and the Emissions(in percent) of Ireland in 1996?
Keep it short and to the point. 36.74. What is the difference between the Emissions(in percent) of Botswana in 1995 and the Emissions(in percent) of Lao PDR in 1996?
Make the answer very short. 42.8. What is the difference between the Emissions(in percent) of Indonesia in 1995 and the Emissions(in percent) of Ireland in 1996?
Your answer should be very brief. -21.68. What is the difference between the Emissions(in percent) in Indonesia in 1995 and the Emissions(in percent) in Lao PDR in 1996?
Offer a terse response. -15.61. What is the difference between the Emissions(in percent) in Ireland in 1995 and the Emissions(in percent) in Lao PDR in 1996?
Offer a very short reply. 7.28. What is the average Emissions(in percent) in Botswana per year?
Your answer should be compact. 80.37. What is the average Emissions(in percent) in Indonesia per year?
Make the answer very short. 8.38. What is the average Emissions(in percent) in Ireland per year?
Provide a short and direct response. 39.23. What is the average Emissions(in percent) in Lao PDR per year?
Keep it short and to the point. 6.47. In the year 1989, what is the difference between the Emissions(in percent) of Botswana and Emissions(in percent) of Indonesia?
Offer a terse response. 95.2. In the year 1989, what is the difference between the Emissions(in percent) of Botswana and Emissions(in percent) of Ireland?
Your answer should be very brief. 51.48. In the year 1989, what is the difference between the Emissions(in percent) in Botswana and Emissions(in percent) in Lao PDR?
Your answer should be compact. 98.44. In the year 1989, what is the difference between the Emissions(in percent) of Indonesia and Emissions(in percent) of Ireland?
Offer a terse response. -43.72. In the year 1989, what is the difference between the Emissions(in percent) in Indonesia and Emissions(in percent) in Lao PDR?
Offer a very short reply. 3.24. In the year 1989, what is the difference between the Emissions(in percent) in Ireland and Emissions(in percent) in Lao PDR?
Make the answer very short. 46.96. In the year 1990, what is the difference between the Emissions(in percent) of Botswana and Emissions(in percent) of Indonesia?
Offer a terse response. 95.01. In the year 1990, what is the difference between the Emissions(in percent) in Botswana and Emissions(in percent) in Ireland?
Offer a very short reply. 57.48. In the year 1990, what is the difference between the Emissions(in percent) in Botswana and Emissions(in percent) in Lao PDR?
Give a very brief answer. 98.1. In the year 1990, what is the difference between the Emissions(in percent) in Indonesia and Emissions(in percent) in Ireland?
Give a very brief answer. -37.53. In the year 1990, what is the difference between the Emissions(in percent) in Indonesia and Emissions(in percent) in Lao PDR?
Provide a succinct answer. 3.09. In the year 1990, what is the difference between the Emissions(in percent) in Ireland and Emissions(in percent) in Lao PDR?
Make the answer very short. 40.62. In the year 1991, what is the difference between the Emissions(in percent) in Botswana and Emissions(in percent) in Indonesia?
Your answer should be very brief. 91.79. In the year 1991, what is the difference between the Emissions(in percent) of Botswana and Emissions(in percent) of Ireland?
Offer a terse response. 57.78. In the year 1991, what is the difference between the Emissions(in percent) of Botswana and Emissions(in percent) of Lao PDR?
Provide a short and direct response. 97.87. In the year 1991, what is the difference between the Emissions(in percent) of Indonesia and Emissions(in percent) of Ireland?
Make the answer very short. -34. In the year 1991, what is the difference between the Emissions(in percent) in Indonesia and Emissions(in percent) in Lao PDR?
Your answer should be compact. 6.08. In the year 1991, what is the difference between the Emissions(in percent) in Ireland and Emissions(in percent) in Lao PDR?
Provide a short and direct response. 40.08. In the year 1992, what is the difference between the Emissions(in percent) in Botswana and Emissions(in percent) in Indonesia?
Give a very brief answer. 67.62. In the year 1992, what is the difference between the Emissions(in percent) in Botswana and Emissions(in percent) in Ireland?
Your answer should be very brief. 32.82. In the year 1992, what is the difference between the Emissions(in percent) of Botswana and Emissions(in percent) of Lao PDR?
Make the answer very short. 72.48. In the year 1992, what is the difference between the Emissions(in percent) in Indonesia and Emissions(in percent) in Ireland?
Provide a short and direct response. -34.8. In the year 1992, what is the difference between the Emissions(in percent) in Indonesia and Emissions(in percent) in Lao PDR?
Your answer should be compact. 4.86. In the year 1992, what is the difference between the Emissions(in percent) in Ireland and Emissions(in percent) in Lao PDR?
Your response must be concise. 39.67. In the year 1993, what is the difference between the Emissions(in percent) in Botswana and Emissions(in percent) in Indonesia?
Offer a terse response. 58.59. In the year 1993, what is the difference between the Emissions(in percent) of Botswana and Emissions(in percent) of Ireland?
Your answer should be very brief. 29.73. In the year 1993, what is the difference between the Emissions(in percent) of Botswana and Emissions(in percent) of Lao PDR?
Keep it short and to the point. 67.03. In the year 1993, what is the difference between the Emissions(in percent) in Indonesia and Emissions(in percent) in Ireland?
Make the answer very short. -28.85. In the year 1993, what is the difference between the Emissions(in percent) in Indonesia and Emissions(in percent) in Lao PDR?
Offer a terse response. 8.44. In the year 1993, what is the difference between the Emissions(in percent) of Ireland and Emissions(in percent) of Lao PDR?
Keep it short and to the point. 37.29. In the year 1994, what is the difference between the Emissions(in percent) of Botswana and Emissions(in percent) of Indonesia?
Your answer should be very brief. 57.42. In the year 1994, what is the difference between the Emissions(in percent) of Botswana and Emissions(in percent) of Ireland?
Offer a very short reply. 34.44. In the year 1994, what is the difference between the Emissions(in percent) of Botswana and Emissions(in percent) of Lao PDR?
Make the answer very short. 68.25. In the year 1994, what is the difference between the Emissions(in percent) in Indonesia and Emissions(in percent) in Ireland?
Provide a succinct answer. -22.98. In the year 1994, what is the difference between the Emissions(in percent) of Indonesia and Emissions(in percent) of Lao PDR?
Ensure brevity in your answer.  10.83. In the year 1994, what is the difference between the Emissions(in percent) of Ireland and Emissions(in percent) of Lao PDR?
Provide a succinct answer. 33.8. In the year 1995, what is the difference between the Emissions(in percent) in Botswana and Emissions(in percent) in Indonesia?
Provide a succinct answer. 58.41. In the year 1995, what is the difference between the Emissions(in percent) in Botswana and Emissions(in percent) in Ireland?
Ensure brevity in your answer.  35.53. In the year 1995, what is the difference between the Emissions(in percent) of Botswana and Emissions(in percent) of Lao PDR?
Make the answer very short. 53.11. In the year 1995, what is the difference between the Emissions(in percent) of Indonesia and Emissions(in percent) of Ireland?
Give a very brief answer. -22.89. In the year 1995, what is the difference between the Emissions(in percent) in Indonesia and Emissions(in percent) in Lao PDR?
Ensure brevity in your answer.  -5.3. In the year 1995, what is the difference between the Emissions(in percent) in Ireland and Emissions(in percent) in Lao PDR?
Ensure brevity in your answer.  17.59. In the year 1996, what is the difference between the Emissions(in percent) in Botswana and Emissions(in percent) in Indonesia?
Offer a terse response. 51.84. In the year 1996, what is the difference between the Emissions(in percent) of Botswana and Emissions(in percent) of Ireland?
Your answer should be very brief. 29.86. In the year 1996, what is the difference between the Emissions(in percent) of Botswana and Emissions(in percent) of Lao PDR?
Offer a terse response. 35.92. In the year 1996, what is the difference between the Emissions(in percent) of Indonesia and Emissions(in percent) of Ireland?
Your response must be concise. -21.99. In the year 1996, what is the difference between the Emissions(in percent) in Indonesia and Emissions(in percent) in Lao PDR?
Keep it short and to the point. -15.92. In the year 1996, what is the difference between the Emissions(in percent) in Ireland and Emissions(in percent) in Lao PDR?
Give a very brief answer. 6.07. What is the ratio of the Emissions(in percent) in Indonesia in 1989 to that in 1990?
Offer a very short reply. 1.03. What is the ratio of the Emissions(in percent) of Ireland in 1989 to that in 1990?
Keep it short and to the point. 1.15. What is the ratio of the Emissions(in percent) of Botswana in 1989 to that in 1991?
Your answer should be very brief. 1.01. What is the ratio of the Emissions(in percent) in Indonesia in 1989 to that in 1991?
Provide a succinct answer. 0.64. What is the ratio of the Emissions(in percent) of Ireland in 1989 to that in 1991?
Keep it short and to the point. 1.17. What is the ratio of the Emissions(in percent) of Lao PDR in 1989 to that in 1991?
Your answer should be very brief. 1.08. What is the ratio of the Emissions(in percent) in Botswana in 1989 to that in 1992?
Give a very brief answer. 1.36. What is the ratio of the Emissions(in percent) of Indonesia in 1989 to that in 1992?
Your answer should be very brief. 0.78. What is the ratio of the Emissions(in percent) in Ireland in 1989 to that in 1992?
Your response must be concise. 1.18. What is the ratio of the Emissions(in percent) in Lao PDR in 1989 to that in 1992?
Give a very brief answer. 1.19. What is the ratio of the Emissions(in percent) in Botswana in 1989 to that in 1993?
Provide a succinct answer. 1.46. What is the ratio of the Emissions(in percent) of Indonesia in 1989 to that in 1993?
Your answer should be very brief. 0.49. What is the ratio of the Emissions(in percent) of Ireland in 1989 to that in 1993?
Make the answer very short. 1.26. What is the ratio of the Emissions(in percent) of Lao PDR in 1989 to that in 1993?
Keep it short and to the point. 1.19. What is the ratio of the Emissions(in percent) of Botswana in 1989 to that in 1994?
Your response must be concise. 1.44. What is the ratio of the Emissions(in percent) of Indonesia in 1989 to that in 1994?
Your answer should be very brief. 0.4. What is the ratio of the Emissions(in percent) of Ireland in 1989 to that in 1994?
Your answer should be very brief. 1.39. What is the ratio of the Emissions(in percent) of Lao PDR in 1989 to that in 1994?
Ensure brevity in your answer.  1.28. What is the ratio of the Emissions(in percent) of Botswana in 1989 to that in 1995?
Ensure brevity in your answer.  1.44. What is the ratio of the Emissions(in percent) of Indonesia in 1989 to that in 1995?
Ensure brevity in your answer.  0.43. What is the ratio of the Emissions(in percent) of Ireland in 1989 to that in 1995?
Your answer should be very brief. 1.42. What is the ratio of the Emissions(in percent) of Lao PDR in 1989 to that in 1995?
Keep it short and to the point. 0.09. What is the ratio of the Emissions(in percent) in Botswana in 1989 to that in 1996?
Offer a very short reply. 1.59. What is the ratio of the Emissions(in percent) in Indonesia in 1989 to that in 1996?
Provide a succinct answer. 0.44. What is the ratio of the Emissions(in percent) in Ireland in 1989 to that in 1996?
Provide a short and direct response. 1.48. What is the ratio of the Emissions(in percent) of Lao PDR in 1989 to that in 1996?
Give a very brief answer. 0.06. What is the ratio of the Emissions(in percent) in Indonesia in 1990 to that in 1991?
Provide a short and direct response. 0.62. What is the ratio of the Emissions(in percent) in Ireland in 1990 to that in 1991?
Offer a very short reply. 1.02. What is the ratio of the Emissions(in percent) in Lao PDR in 1990 to that in 1991?
Provide a succinct answer. 1.08. What is the ratio of the Emissions(in percent) in Botswana in 1990 to that in 1992?
Offer a very short reply. 1.35. What is the ratio of the Emissions(in percent) of Indonesia in 1990 to that in 1992?
Provide a succinct answer. 0.75. What is the ratio of the Emissions(in percent) in Ireland in 1990 to that in 1992?
Your answer should be very brief. 1.03. What is the ratio of the Emissions(in percent) in Lao PDR in 1990 to that in 1992?
Make the answer very short. 1.19. What is the ratio of the Emissions(in percent) of Botswana in 1990 to that in 1993?
Your answer should be very brief. 1.46. What is the ratio of the Emissions(in percent) of Indonesia in 1990 to that in 1993?
Offer a terse response. 0.48. What is the ratio of the Emissions(in percent) of Ireland in 1990 to that in 1993?
Make the answer very short. 1.09. What is the ratio of the Emissions(in percent) in Lao PDR in 1990 to that in 1993?
Keep it short and to the point. 1.19. What is the ratio of the Emissions(in percent) of Botswana in 1990 to that in 1994?
Your answer should be compact. 1.43. What is the ratio of the Emissions(in percent) in Indonesia in 1990 to that in 1994?
Provide a short and direct response. 0.39. What is the ratio of the Emissions(in percent) of Ireland in 1990 to that in 1994?
Your answer should be very brief. 1.2. What is the ratio of the Emissions(in percent) of Lao PDR in 1990 to that in 1994?
Your response must be concise. 1.28. What is the ratio of the Emissions(in percent) of Botswana in 1990 to that in 1995?
Keep it short and to the point. 1.43. What is the ratio of the Emissions(in percent) of Indonesia in 1990 to that in 1995?
Ensure brevity in your answer.  0.41. What is the ratio of the Emissions(in percent) of Ireland in 1990 to that in 1995?
Make the answer very short. 1.24. What is the ratio of the Emissions(in percent) of Lao PDR in 1990 to that in 1995?
Provide a short and direct response. 0.09. What is the ratio of the Emissions(in percent) in Botswana in 1990 to that in 1996?
Your response must be concise. 1.59. What is the ratio of the Emissions(in percent) of Indonesia in 1990 to that in 1996?
Ensure brevity in your answer.  0.43. What is the ratio of the Emissions(in percent) of Ireland in 1990 to that in 1996?
Provide a short and direct response. 1.28. What is the ratio of the Emissions(in percent) in Lao PDR in 1990 to that in 1996?
Ensure brevity in your answer.  0.06. What is the ratio of the Emissions(in percent) in Botswana in 1991 to that in 1992?
Offer a terse response. 1.35. What is the ratio of the Emissions(in percent) of Indonesia in 1991 to that in 1992?
Your answer should be compact. 1.22. What is the ratio of the Emissions(in percent) of Ireland in 1991 to that in 1992?
Your response must be concise. 1.01. What is the ratio of the Emissions(in percent) of Lao PDR in 1991 to that in 1992?
Your response must be concise. 1.1. What is the ratio of the Emissions(in percent) of Botswana in 1991 to that in 1993?
Offer a very short reply. 1.45. What is the ratio of the Emissions(in percent) in Indonesia in 1991 to that in 1993?
Offer a terse response. 0.77. What is the ratio of the Emissions(in percent) in Ireland in 1991 to that in 1993?
Offer a terse response. 1.08. What is the ratio of the Emissions(in percent) in Lao PDR in 1991 to that in 1993?
Your response must be concise. 1.1. What is the ratio of the Emissions(in percent) in Botswana in 1991 to that in 1994?
Your answer should be very brief. 1.43. What is the ratio of the Emissions(in percent) of Ireland in 1991 to that in 1994?
Your response must be concise. 1.19. What is the ratio of the Emissions(in percent) of Lao PDR in 1991 to that in 1994?
Give a very brief answer. 1.19. What is the ratio of the Emissions(in percent) in Botswana in 1991 to that in 1995?
Keep it short and to the point. 1.43. What is the ratio of the Emissions(in percent) in Indonesia in 1991 to that in 1995?
Your response must be concise. 0.67. What is the ratio of the Emissions(in percent) in Ireland in 1991 to that in 1995?
Your answer should be very brief. 1.22. What is the ratio of the Emissions(in percent) of Lao PDR in 1991 to that in 1995?
Your response must be concise. 0.09. What is the ratio of the Emissions(in percent) in Botswana in 1991 to that in 1996?
Keep it short and to the point. 1.58. What is the ratio of the Emissions(in percent) in Indonesia in 1991 to that in 1996?
Offer a very short reply. 0.69. What is the ratio of the Emissions(in percent) of Ireland in 1991 to that in 1996?
Provide a succinct answer. 1.26. What is the ratio of the Emissions(in percent) in Lao PDR in 1991 to that in 1996?
Offer a very short reply. 0.05. What is the ratio of the Emissions(in percent) of Botswana in 1992 to that in 1993?
Ensure brevity in your answer.  1.08. What is the ratio of the Emissions(in percent) of Indonesia in 1992 to that in 1993?
Provide a short and direct response. 0.63. What is the ratio of the Emissions(in percent) in Ireland in 1992 to that in 1993?
Provide a succinct answer. 1.06. What is the ratio of the Emissions(in percent) of Botswana in 1992 to that in 1994?
Offer a terse response. 1.06. What is the ratio of the Emissions(in percent) in Indonesia in 1992 to that in 1994?
Give a very brief answer. 0.51. What is the ratio of the Emissions(in percent) in Ireland in 1992 to that in 1994?
Make the answer very short. 1.17. What is the ratio of the Emissions(in percent) of Lao PDR in 1992 to that in 1994?
Offer a very short reply. 1.08. What is the ratio of the Emissions(in percent) of Botswana in 1992 to that in 1995?
Ensure brevity in your answer.  1.06. What is the ratio of the Emissions(in percent) of Indonesia in 1992 to that in 1995?
Your response must be concise. 0.55. What is the ratio of the Emissions(in percent) of Ireland in 1992 to that in 1995?
Your answer should be very brief. 1.2. What is the ratio of the Emissions(in percent) of Lao PDR in 1992 to that in 1995?
Offer a very short reply. 0.08. What is the ratio of the Emissions(in percent) in Botswana in 1992 to that in 1996?
Keep it short and to the point. 1.18. What is the ratio of the Emissions(in percent) of Indonesia in 1992 to that in 1996?
Give a very brief answer. 0.57. What is the ratio of the Emissions(in percent) of Ireland in 1992 to that in 1996?
Your answer should be very brief. 1.25. What is the ratio of the Emissions(in percent) in Lao PDR in 1992 to that in 1996?
Your answer should be very brief. 0.05. What is the ratio of the Emissions(in percent) in Botswana in 1993 to that in 1994?
Provide a short and direct response. 0.98. What is the ratio of the Emissions(in percent) in Indonesia in 1993 to that in 1994?
Offer a very short reply. 0.81. What is the ratio of the Emissions(in percent) in Ireland in 1993 to that in 1994?
Make the answer very short. 1.1. What is the ratio of the Emissions(in percent) of Lao PDR in 1993 to that in 1994?
Give a very brief answer. 1.08. What is the ratio of the Emissions(in percent) of Botswana in 1993 to that in 1995?
Give a very brief answer. 0.98. What is the ratio of the Emissions(in percent) of Indonesia in 1993 to that in 1995?
Offer a terse response. 0.87. What is the ratio of the Emissions(in percent) in Ireland in 1993 to that in 1995?
Provide a short and direct response. 1.13. What is the ratio of the Emissions(in percent) of Lao PDR in 1993 to that in 1995?
Keep it short and to the point. 0.08. What is the ratio of the Emissions(in percent) in Botswana in 1993 to that in 1996?
Offer a terse response. 1.09. What is the ratio of the Emissions(in percent) in Indonesia in 1993 to that in 1996?
Your answer should be compact. 0.9. What is the ratio of the Emissions(in percent) in Ireland in 1993 to that in 1996?
Your response must be concise. 1.17. What is the ratio of the Emissions(in percent) of Lao PDR in 1993 to that in 1996?
Ensure brevity in your answer.  0.05. What is the ratio of the Emissions(in percent) in Indonesia in 1994 to that in 1995?
Your answer should be very brief. 1.08. What is the ratio of the Emissions(in percent) of Ireland in 1994 to that in 1995?
Offer a very short reply. 1.03. What is the ratio of the Emissions(in percent) in Lao PDR in 1994 to that in 1995?
Your response must be concise. 0.07. What is the ratio of the Emissions(in percent) in Botswana in 1994 to that in 1996?
Provide a short and direct response. 1.11. What is the ratio of the Emissions(in percent) in Indonesia in 1994 to that in 1996?
Make the answer very short. 1.11. What is the ratio of the Emissions(in percent) of Ireland in 1994 to that in 1996?
Keep it short and to the point. 1.07. What is the ratio of the Emissions(in percent) of Lao PDR in 1994 to that in 1996?
Give a very brief answer. 0.05. What is the ratio of the Emissions(in percent) in Botswana in 1995 to that in 1996?
Your response must be concise. 1.11. What is the ratio of the Emissions(in percent) of Indonesia in 1995 to that in 1996?
Your answer should be very brief. 1.03. What is the ratio of the Emissions(in percent) in Ireland in 1995 to that in 1996?
Provide a short and direct response. 1.04. What is the ratio of the Emissions(in percent) in Lao PDR in 1995 to that in 1996?
Your answer should be very brief. 0.62. What is the difference between the highest and the second highest Emissions(in percent) of Botswana?
Provide a short and direct response. 0.34. What is the difference between the highest and the second highest Emissions(in percent) of Indonesia?
Give a very brief answer. 0.84. What is the difference between the highest and the second highest Emissions(in percent) of Ireland?
Provide a succinct answer. 6.34. What is the difference between the highest and the second highest Emissions(in percent) in Lao PDR?
Keep it short and to the point. 10.31. What is the difference between the highest and the lowest Emissions(in percent) of Botswana?
Provide a succinct answer. 37.27. What is the difference between the highest and the lowest Emissions(in percent) in Indonesia?
Provide a short and direct response. 7.4. What is the difference between the highest and the lowest Emissions(in percent) in Ireland?
Ensure brevity in your answer.  15.64. What is the difference between the highest and the lowest Emissions(in percent) of Lao PDR?
Give a very brief answer. 25.59. 